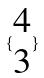Convert formula to latex. <formula><loc_0><loc_0><loc_500><loc_500>\{ \begin{matrix} 4 \\ 3 \end{matrix} \}</formula> 